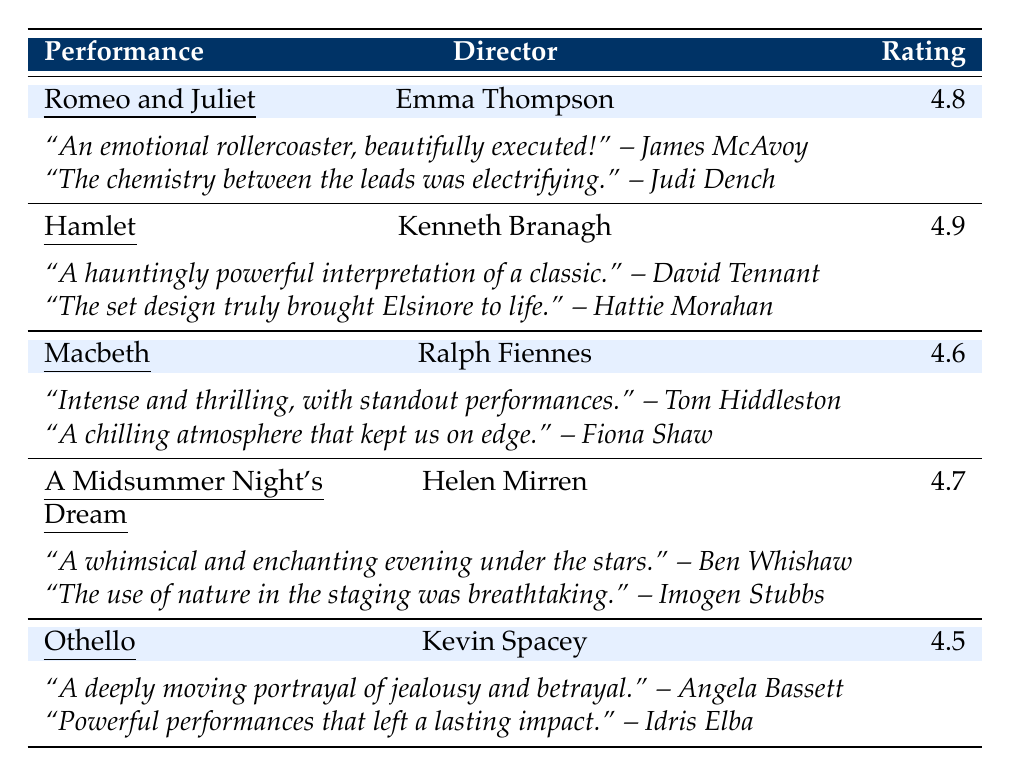What is the highest audience rating among the performances? The table shows the audience ratings for each performance. Scanning through, "Hamlet" has the highest rating of 4.9.
Answer: 4.9 Who directed "A Midsummer Night's Dream"? The table lists the directors next to each performance. Under the performance "A Midsummer Night's Dream," the director is Helen Mirren.
Answer: Helen Mirren Which performance has the lowest audience rating, and what is that rating? The audience ratings in the table show that "Othello" has the lowest rating of 4.5.
Answer: Othello, 4.5 Which actors provided reviews for "Macbeth"? The table features two reviews for "Macbeth." The reviewers are Tom Hiddleston and Fiona Shaw.
Answer: Tom Hiddleston and Fiona Shaw Did "Romeo and Juliet" receive a higher audience rating than "Othello"? The audience rating for "Romeo and Juliet" is 4.8 while "Othello" is 4.5. Since 4.8 is greater than 4.5, the answer is yes.
Answer: Yes What was the audience rating for the performance directed by Kenneth Branagh? By identifying the performance directed by Kenneth Branagh, which is "Hamlet," we can find its audience rating of 4.9.
Answer: 4.9 How many reviews were given for "A Midsummer Night's Dream"? There are two reviews listed under "A Midsummer Night's Dream." Ben Whishaw and Imogen Stubbs provided these reviews.
Answer: 2 What is the average audience rating of the performances? The ratings given are 4.8, 4.9, 4.6, 4.7, and 4.5. Summing these ratings (4.8 + 4.9 + 4.6 + 4.7 + 4.5 = 24.5) and dividing by the number of performances (5) gives an average of 24.5/5 = 4.9.
Answer: 4.9 Which performance received a review that described it as "hauntingly powerful"? The review that describes a performance as "hauntingly powerful" belongs to "Hamlet," based on David Tennant's comment.
Answer: Hamlet Was there any performance that received an audience rating of 4.6 or lower? The audience ratings in the table show that "Othello" has a rating of 4.5, which is 4.6 or lower; therefore, the answer is yes.
Answer: Yes 